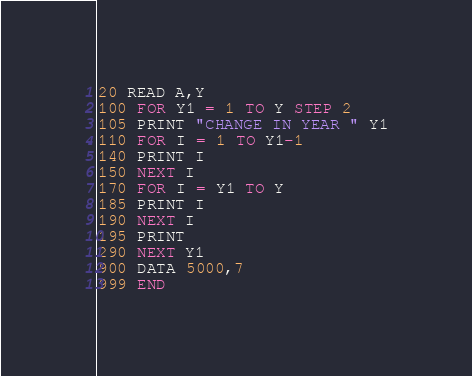Convert code to text. <code><loc_0><loc_0><loc_500><loc_500><_VisualBasic_>20 READ A,Y
100 FOR Y1 = 1 TO Y STEP 2
105 PRINT "CHANGE IN YEAR " Y1
110 FOR I = 1 TO Y1-1
140 PRINT I
150 NEXT I
170 FOR I = Y1 TO Y
185 PRINT I
190 NEXT I
195 PRINT
290 NEXT Y1
900 DATA 5000,7
999 END

</code> 